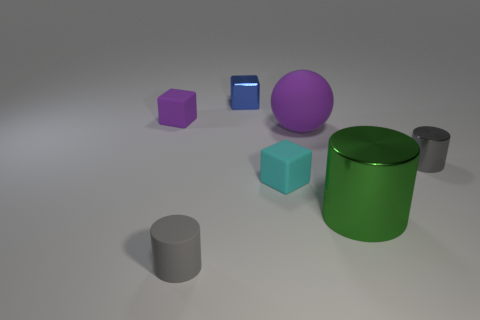Subtract all small blue blocks. How many blocks are left? 2 Add 1 large brown balls. How many objects exist? 8 Subtract all gray cylinders. How many cylinders are left? 1 Subtract all cylinders. How many objects are left? 4 Subtract 1 blocks. How many blocks are left? 2 Subtract all gray balls. How many gray cylinders are left? 2 Add 6 tiny gray cylinders. How many tiny gray cylinders are left? 8 Add 1 rubber cylinders. How many rubber cylinders exist? 2 Subtract 0 red cylinders. How many objects are left? 7 Subtract all yellow spheres. Subtract all red cylinders. How many spheres are left? 1 